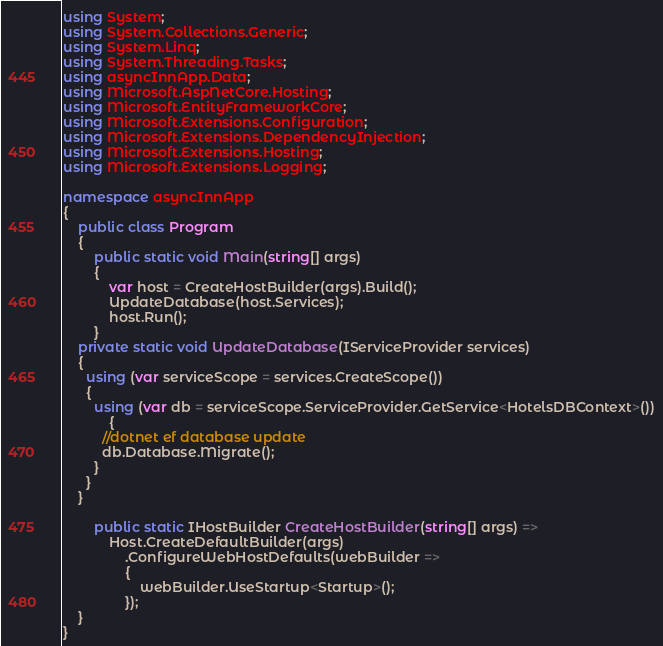Convert code to text. <code><loc_0><loc_0><loc_500><loc_500><_C#_>using System;
using System.Collections.Generic;
using System.Linq;
using System.Threading.Tasks;
using asyncInnApp.Data;
using Microsoft.AspNetCore.Hosting;
using Microsoft.EntityFrameworkCore;
using Microsoft.Extensions.Configuration;
using Microsoft.Extensions.DependencyInjection;
using Microsoft.Extensions.Hosting;
using Microsoft.Extensions.Logging;

namespace asyncInnApp
{
    public class Program
    {
        public static void Main(string[] args)
        {
            var host = CreateHostBuilder(args).Build();
            UpdateDatabase(host.Services);
            host.Run();
        }
    private static void UpdateDatabase(IServiceProvider services)
    {
      using (var serviceScope = services.CreateScope())
      {
        using (var db = serviceScope.ServiceProvider.GetService<HotelsDBContext>())
            {
          //dotnet ef database update
          db.Database.Migrate();
        }
      }
    }

        public static IHostBuilder CreateHostBuilder(string[] args) =>
            Host.CreateDefaultBuilder(args)
                .ConfigureWebHostDefaults(webBuilder =>
                {
                    webBuilder.UseStartup<Startup>();
                });
    }
}
</code> 